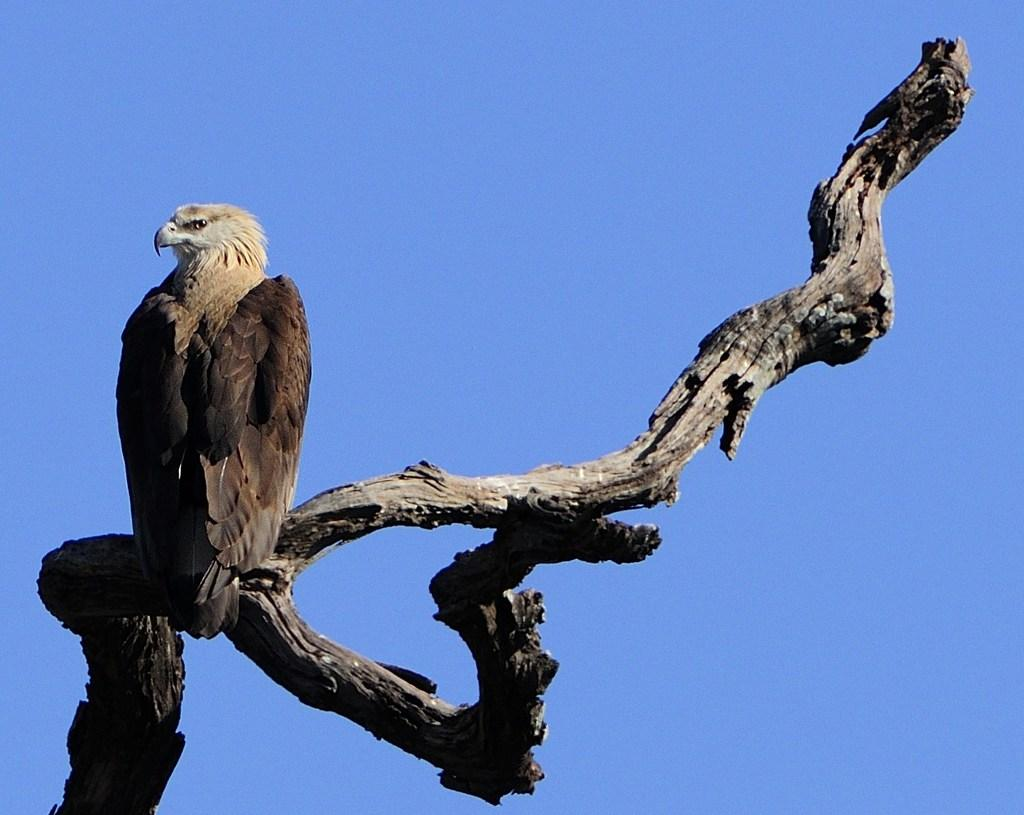What type of animal can be seen in the image? There is a bird in the image. Where is the bird located in the image? The bird is standing on the branch of a tree. What type of lumber is the bird using to build its nest in the image? There is no nest or lumber present in the image; it only features a bird standing on a tree branch. 